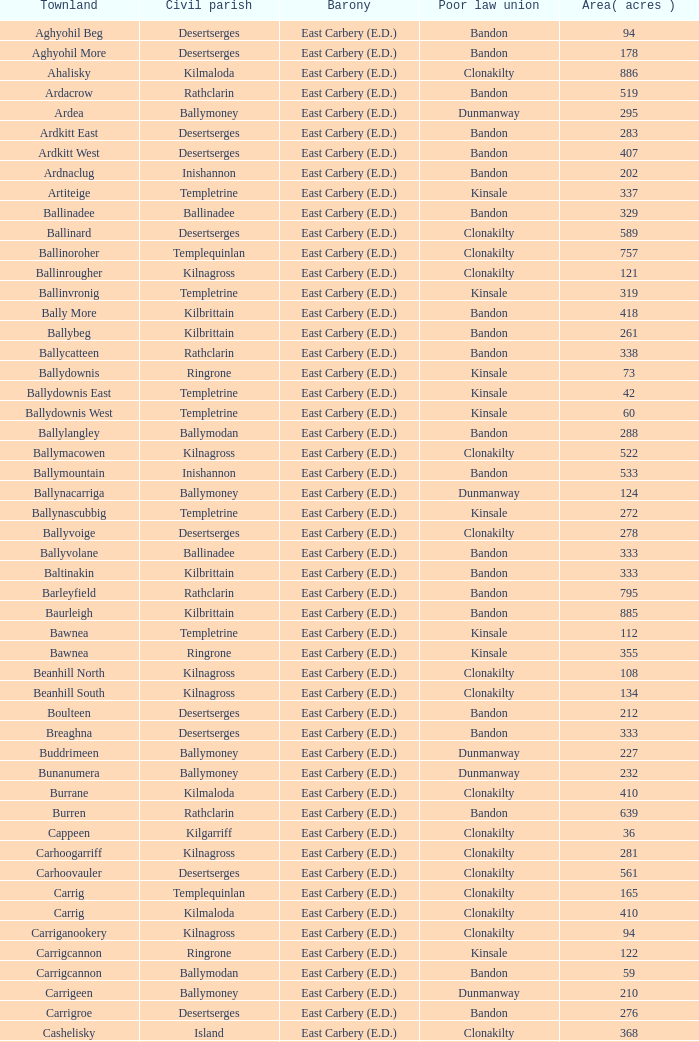What is the poor law union of the Lackenagobidane townland? Clonakilty. 